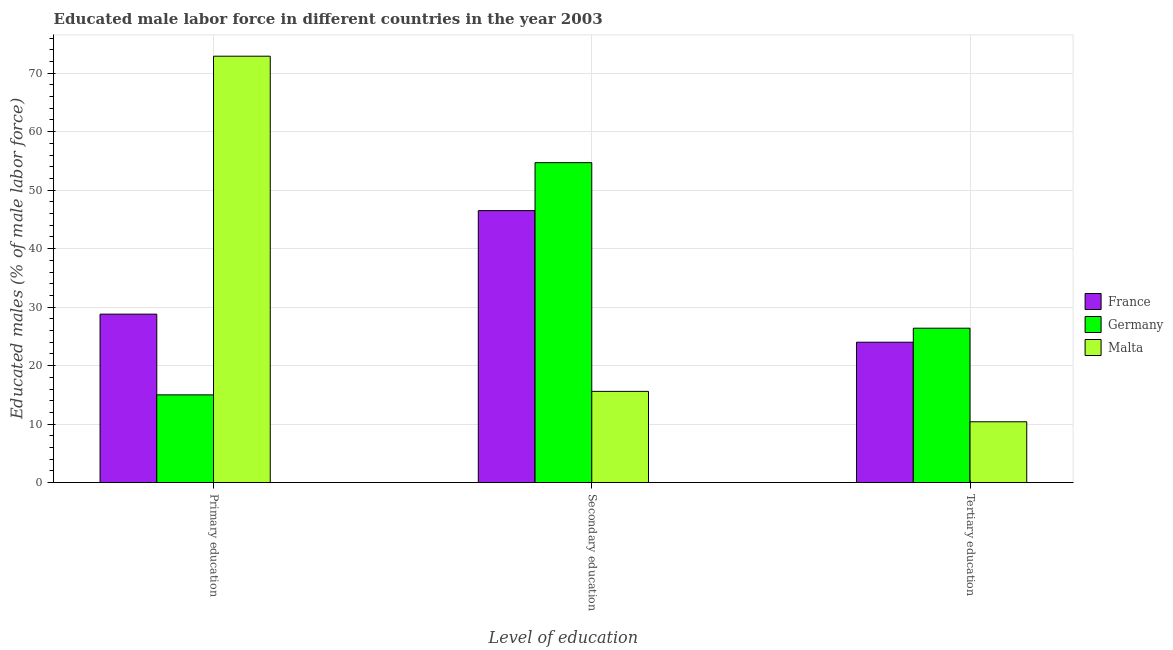How many different coloured bars are there?
Offer a terse response. 3. How many bars are there on the 2nd tick from the left?
Ensure brevity in your answer.  3. What is the label of the 2nd group of bars from the left?
Ensure brevity in your answer.  Secondary education. What is the percentage of male labor force who received primary education in France?
Give a very brief answer. 28.8. Across all countries, what is the maximum percentage of male labor force who received tertiary education?
Your response must be concise. 26.4. In which country was the percentage of male labor force who received primary education maximum?
Your answer should be compact. Malta. In which country was the percentage of male labor force who received secondary education minimum?
Your answer should be very brief. Malta. What is the total percentage of male labor force who received secondary education in the graph?
Give a very brief answer. 116.8. What is the difference between the percentage of male labor force who received primary education in Malta and that in Germany?
Your answer should be very brief. 57.9. What is the difference between the percentage of male labor force who received secondary education in Germany and the percentage of male labor force who received tertiary education in France?
Make the answer very short. 30.7. What is the average percentage of male labor force who received tertiary education per country?
Provide a short and direct response. 20.27. What is the difference between the percentage of male labor force who received tertiary education and percentage of male labor force who received secondary education in France?
Give a very brief answer. -22.5. What is the ratio of the percentage of male labor force who received primary education in Germany to that in Malta?
Keep it short and to the point. 0.21. Is the percentage of male labor force who received primary education in Malta less than that in France?
Make the answer very short. No. Is the difference between the percentage of male labor force who received secondary education in Malta and France greater than the difference between the percentage of male labor force who received primary education in Malta and France?
Provide a short and direct response. No. What is the difference between the highest and the second highest percentage of male labor force who received primary education?
Keep it short and to the point. 44.1. What is the difference between the highest and the lowest percentage of male labor force who received primary education?
Offer a terse response. 57.9. Is the sum of the percentage of male labor force who received tertiary education in Germany and France greater than the maximum percentage of male labor force who received secondary education across all countries?
Provide a short and direct response. No. What does the 1st bar from the right in Secondary education represents?
Your answer should be very brief. Malta. How many countries are there in the graph?
Offer a very short reply. 3. Does the graph contain any zero values?
Provide a short and direct response. No. Does the graph contain grids?
Your answer should be very brief. Yes. How many legend labels are there?
Your response must be concise. 3. What is the title of the graph?
Provide a short and direct response. Educated male labor force in different countries in the year 2003. Does "Pacific island small states" appear as one of the legend labels in the graph?
Provide a succinct answer. No. What is the label or title of the X-axis?
Give a very brief answer. Level of education. What is the label or title of the Y-axis?
Ensure brevity in your answer.  Educated males (% of male labor force). What is the Educated males (% of male labor force) in France in Primary education?
Offer a terse response. 28.8. What is the Educated males (% of male labor force) of Germany in Primary education?
Offer a very short reply. 15. What is the Educated males (% of male labor force) of Malta in Primary education?
Offer a terse response. 72.9. What is the Educated males (% of male labor force) in France in Secondary education?
Offer a terse response. 46.5. What is the Educated males (% of male labor force) in Germany in Secondary education?
Your answer should be very brief. 54.7. What is the Educated males (% of male labor force) of Malta in Secondary education?
Offer a terse response. 15.6. What is the Educated males (% of male labor force) in Germany in Tertiary education?
Your response must be concise. 26.4. What is the Educated males (% of male labor force) in Malta in Tertiary education?
Give a very brief answer. 10.4. Across all Level of education, what is the maximum Educated males (% of male labor force) in France?
Offer a terse response. 46.5. Across all Level of education, what is the maximum Educated males (% of male labor force) in Germany?
Offer a terse response. 54.7. Across all Level of education, what is the maximum Educated males (% of male labor force) in Malta?
Provide a short and direct response. 72.9. Across all Level of education, what is the minimum Educated males (% of male labor force) of France?
Your response must be concise. 24. Across all Level of education, what is the minimum Educated males (% of male labor force) in Malta?
Your answer should be very brief. 10.4. What is the total Educated males (% of male labor force) in France in the graph?
Offer a terse response. 99.3. What is the total Educated males (% of male labor force) in Germany in the graph?
Keep it short and to the point. 96.1. What is the total Educated males (% of male labor force) of Malta in the graph?
Your answer should be compact. 98.9. What is the difference between the Educated males (% of male labor force) in France in Primary education and that in Secondary education?
Your answer should be very brief. -17.7. What is the difference between the Educated males (% of male labor force) of Germany in Primary education and that in Secondary education?
Provide a short and direct response. -39.7. What is the difference between the Educated males (% of male labor force) in Malta in Primary education and that in Secondary education?
Offer a terse response. 57.3. What is the difference between the Educated males (% of male labor force) of France in Primary education and that in Tertiary education?
Your answer should be very brief. 4.8. What is the difference between the Educated males (% of male labor force) in Germany in Primary education and that in Tertiary education?
Give a very brief answer. -11.4. What is the difference between the Educated males (% of male labor force) in Malta in Primary education and that in Tertiary education?
Provide a short and direct response. 62.5. What is the difference between the Educated males (% of male labor force) in Germany in Secondary education and that in Tertiary education?
Your response must be concise. 28.3. What is the difference between the Educated males (% of male labor force) of Malta in Secondary education and that in Tertiary education?
Provide a succinct answer. 5.2. What is the difference between the Educated males (% of male labor force) in France in Primary education and the Educated males (% of male labor force) in Germany in Secondary education?
Offer a terse response. -25.9. What is the difference between the Educated males (% of male labor force) in France in Primary education and the Educated males (% of male labor force) in Malta in Secondary education?
Your answer should be compact. 13.2. What is the difference between the Educated males (% of male labor force) in Germany in Primary education and the Educated males (% of male labor force) in Malta in Secondary education?
Offer a terse response. -0.6. What is the difference between the Educated males (% of male labor force) of France in Primary education and the Educated males (% of male labor force) of Malta in Tertiary education?
Offer a terse response. 18.4. What is the difference between the Educated males (% of male labor force) of France in Secondary education and the Educated males (% of male labor force) of Germany in Tertiary education?
Your answer should be compact. 20.1. What is the difference between the Educated males (% of male labor force) in France in Secondary education and the Educated males (% of male labor force) in Malta in Tertiary education?
Offer a very short reply. 36.1. What is the difference between the Educated males (% of male labor force) in Germany in Secondary education and the Educated males (% of male labor force) in Malta in Tertiary education?
Make the answer very short. 44.3. What is the average Educated males (% of male labor force) of France per Level of education?
Offer a terse response. 33.1. What is the average Educated males (% of male labor force) of Germany per Level of education?
Your answer should be very brief. 32.03. What is the average Educated males (% of male labor force) in Malta per Level of education?
Your answer should be very brief. 32.97. What is the difference between the Educated males (% of male labor force) in France and Educated males (% of male labor force) in Malta in Primary education?
Your response must be concise. -44.1. What is the difference between the Educated males (% of male labor force) of Germany and Educated males (% of male labor force) of Malta in Primary education?
Provide a short and direct response. -57.9. What is the difference between the Educated males (% of male labor force) in France and Educated males (% of male labor force) in Germany in Secondary education?
Your response must be concise. -8.2. What is the difference between the Educated males (% of male labor force) in France and Educated males (% of male labor force) in Malta in Secondary education?
Your response must be concise. 30.9. What is the difference between the Educated males (% of male labor force) in Germany and Educated males (% of male labor force) in Malta in Secondary education?
Ensure brevity in your answer.  39.1. What is the difference between the Educated males (% of male labor force) in France and Educated males (% of male labor force) in Malta in Tertiary education?
Ensure brevity in your answer.  13.6. What is the difference between the Educated males (% of male labor force) in Germany and Educated males (% of male labor force) in Malta in Tertiary education?
Provide a succinct answer. 16. What is the ratio of the Educated males (% of male labor force) in France in Primary education to that in Secondary education?
Keep it short and to the point. 0.62. What is the ratio of the Educated males (% of male labor force) in Germany in Primary education to that in Secondary education?
Offer a terse response. 0.27. What is the ratio of the Educated males (% of male labor force) in Malta in Primary education to that in Secondary education?
Ensure brevity in your answer.  4.67. What is the ratio of the Educated males (% of male labor force) in Germany in Primary education to that in Tertiary education?
Your response must be concise. 0.57. What is the ratio of the Educated males (% of male labor force) of Malta in Primary education to that in Tertiary education?
Ensure brevity in your answer.  7.01. What is the ratio of the Educated males (% of male labor force) in France in Secondary education to that in Tertiary education?
Your answer should be compact. 1.94. What is the ratio of the Educated males (% of male labor force) of Germany in Secondary education to that in Tertiary education?
Offer a very short reply. 2.07. What is the ratio of the Educated males (% of male labor force) in Malta in Secondary education to that in Tertiary education?
Ensure brevity in your answer.  1.5. What is the difference between the highest and the second highest Educated males (% of male labor force) in Germany?
Your response must be concise. 28.3. What is the difference between the highest and the second highest Educated males (% of male labor force) in Malta?
Ensure brevity in your answer.  57.3. What is the difference between the highest and the lowest Educated males (% of male labor force) in Germany?
Keep it short and to the point. 39.7. What is the difference between the highest and the lowest Educated males (% of male labor force) of Malta?
Give a very brief answer. 62.5. 